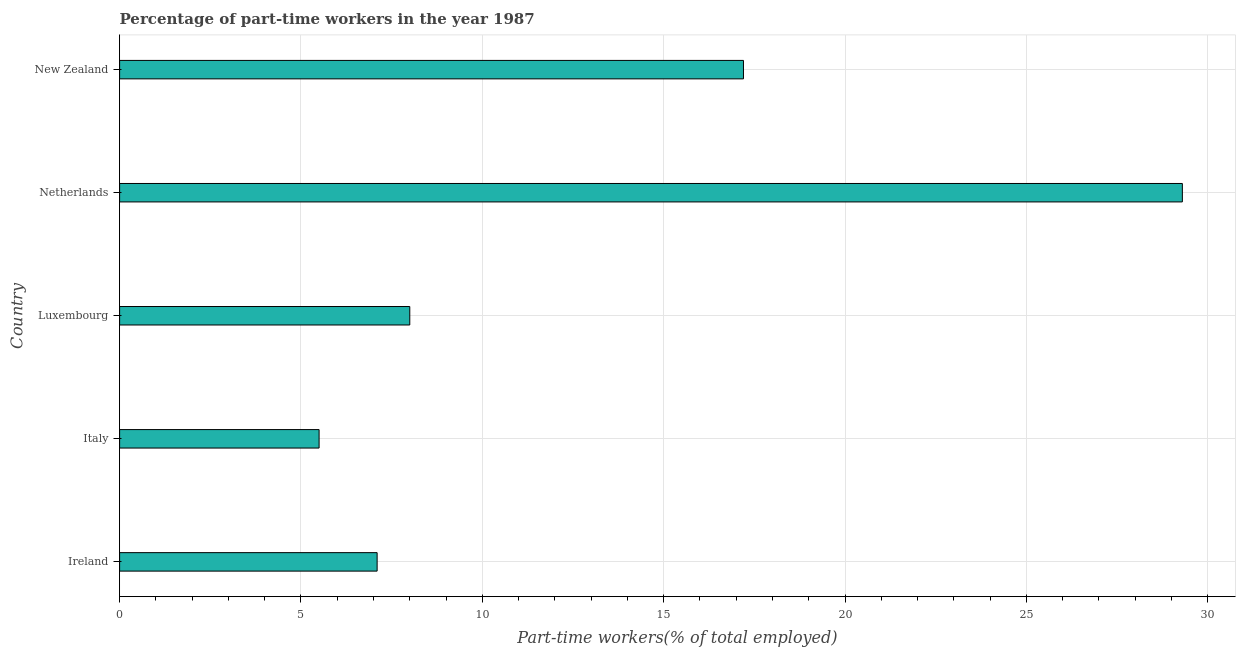Does the graph contain grids?
Offer a very short reply. Yes. What is the title of the graph?
Ensure brevity in your answer.  Percentage of part-time workers in the year 1987. What is the label or title of the X-axis?
Your response must be concise. Part-time workers(% of total employed). What is the percentage of part-time workers in Netherlands?
Give a very brief answer. 29.3. Across all countries, what is the maximum percentage of part-time workers?
Ensure brevity in your answer.  29.3. Across all countries, what is the minimum percentage of part-time workers?
Provide a succinct answer. 5.5. In which country was the percentage of part-time workers minimum?
Offer a terse response. Italy. What is the sum of the percentage of part-time workers?
Give a very brief answer. 67.1. What is the difference between the percentage of part-time workers in Ireland and Italy?
Your answer should be compact. 1.6. What is the average percentage of part-time workers per country?
Ensure brevity in your answer.  13.42. What is the median percentage of part-time workers?
Ensure brevity in your answer.  8. In how many countries, is the percentage of part-time workers greater than 4 %?
Provide a short and direct response. 5. What is the ratio of the percentage of part-time workers in Luxembourg to that in New Zealand?
Offer a very short reply. 0.47. Is the percentage of part-time workers in Netherlands less than that in New Zealand?
Your answer should be very brief. No. Is the difference between the percentage of part-time workers in Italy and Netherlands greater than the difference between any two countries?
Make the answer very short. Yes. What is the difference between the highest and the second highest percentage of part-time workers?
Ensure brevity in your answer.  12.1. What is the difference between the highest and the lowest percentage of part-time workers?
Make the answer very short. 23.8. How many countries are there in the graph?
Make the answer very short. 5. What is the Part-time workers(% of total employed) of Ireland?
Make the answer very short. 7.1. What is the Part-time workers(% of total employed) in Netherlands?
Provide a succinct answer. 29.3. What is the Part-time workers(% of total employed) of New Zealand?
Your response must be concise. 17.2. What is the difference between the Part-time workers(% of total employed) in Ireland and Italy?
Provide a succinct answer. 1.6. What is the difference between the Part-time workers(% of total employed) in Ireland and Luxembourg?
Your answer should be compact. -0.9. What is the difference between the Part-time workers(% of total employed) in Ireland and Netherlands?
Ensure brevity in your answer.  -22.2. What is the difference between the Part-time workers(% of total employed) in Italy and Netherlands?
Offer a very short reply. -23.8. What is the difference between the Part-time workers(% of total employed) in Italy and New Zealand?
Give a very brief answer. -11.7. What is the difference between the Part-time workers(% of total employed) in Luxembourg and Netherlands?
Offer a very short reply. -21.3. What is the ratio of the Part-time workers(% of total employed) in Ireland to that in Italy?
Provide a succinct answer. 1.29. What is the ratio of the Part-time workers(% of total employed) in Ireland to that in Luxembourg?
Keep it short and to the point. 0.89. What is the ratio of the Part-time workers(% of total employed) in Ireland to that in Netherlands?
Offer a terse response. 0.24. What is the ratio of the Part-time workers(% of total employed) in Ireland to that in New Zealand?
Your answer should be very brief. 0.41. What is the ratio of the Part-time workers(% of total employed) in Italy to that in Luxembourg?
Ensure brevity in your answer.  0.69. What is the ratio of the Part-time workers(% of total employed) in Italy to that in Netherlands?
Provide a succinct answer. 0.19. What is the ratio of the Part-time workers(% of total employed) in Italy to that in New Zealand?
Give a very brief answer. 0.32. What is the ratio of the Part-time workers(% of total employed) in Luxembourg to that in Netherlands?
Provide a short and direct response. 0.27. What is the ratio of the Part-time workers(% of total employed) in Luxembourg to that in New Zealand?
Your response must be concise. 0.47. What is the ratio of the Part-time workers(% of total employed) in Netherlands to that in New Zealand?
Provide a succinct answer. 1.7. 